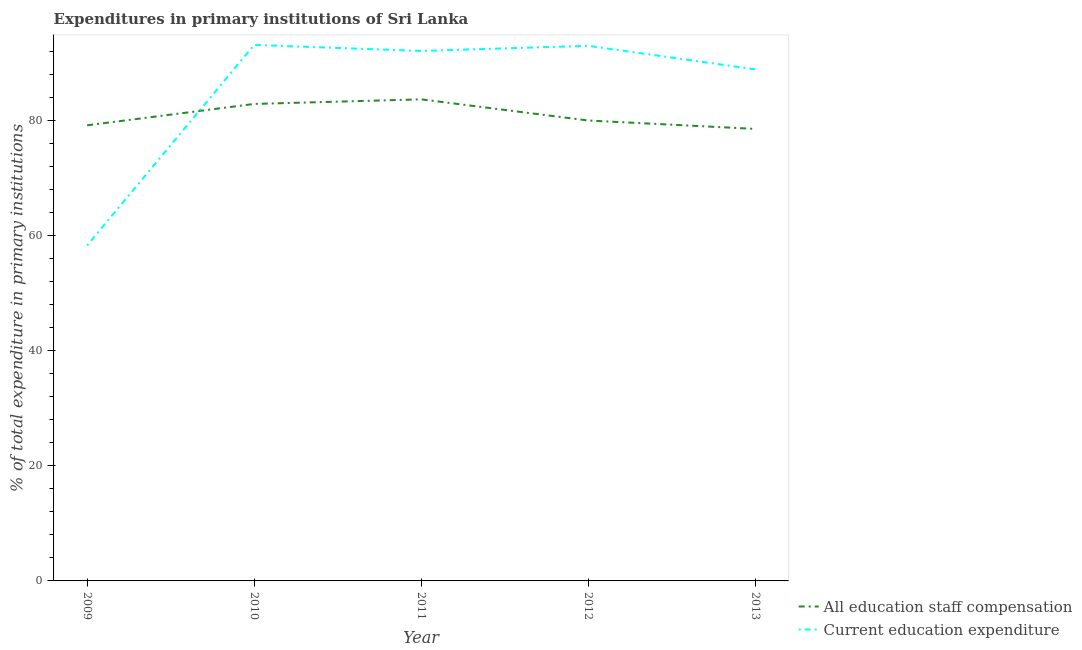What is the expenditure in staff compensation in 2012?
Provide a short and direct response. 80. Across all years, what is the maximum expenditure in education?
Your response must be concise. 93.14. Across all years, what is the minimum expenditure in education?
Keep it short and to the point. 58.29. What is the total expenditure in education in the graph?
Your answer should be compact. 425.41. What is the difference between the expenditure in education in 2012 and that in 2013?
Make the answer very short. 4.09. What is the difference between the expenditure in education in 2013 and the expenditure in staff compensation in 2012?
Keep it short and to the point. 8.89. What is the average expenditure in staff compensation per year?
Your response must be concise. 80.86. In the year 2009, what is the difference between the expenditure in education and expenditure in staff compensation?
Offer a very short reply. -20.88. In how many years, is the expenditure in education greater than 28 %?
Offer a very short reply. 5. What is the ratio of the expenditure in education in 2009 to that in 2012?
Provide a short and direct response. 0.63. Is the expenditure in staff compensation in 2009 less than that in 2010?
Your answer should be compact. Yes. Is the difference between the expenditure in education in 2012 and 2013 greater than the difference between the expenditure in staff compensation in 2012 and 2013?
Give a very brief answer. Yes. What is the difference between the highest and the second highest expenditure in staff compensation?
Make the answer very short. 0.8. What is the difference between the highest and the lowest expenditure in staff compensation?
Offer a terse response. 5.14. Does the expenditure in education monotonically increase over the years?
Make the answer very short. No. Is the expenditure in education strictly greater than the expenditure in staff compensation over the years?
Keep it short and to the point. No. How many years are there in the graph?
Ensure brevity in your answer.  5. What is the difference between two consecutive major ticks on the Y-axis?
Keep it short and to the point. 20. Does the graph contain any zero values?
Ensure brevity in your answer.  No. Does the graph contain grids?
Provide a short and direct response. No. How are the legend labels stacked?
Make the answer very short. Vertical. What is the title of the graph?
Your answer should be very brief. Expenditures in primary institutions of Sri Lanka. What is the label or title of the Y-axis?
Your answer should be very brief. % of total expenditure in primary institutions. What is the % of total expenditure in primary institutions of All education staff compensation in 2009?
Provide a short and direct response. 79.17. What is the % of total expenditure in primary institutions in Current education expenditure in 2009?
Make the answer very short. 58.29. What is the % of total expenditure in primary institutions of All education staff compensation in 2010?
Your answer should be very brief. 82.88. What is the % of total expenditure in primary institutions of Current education expenditure in 2010?
Provide a succinct answer. 93.14. What is the % of total expenditure in primary institutions in All education staff compensation in 2011?
Ensure brevity in your answer.  83.68. What is the % of total expenditure in primary institutions of Current education expenditure in 2011?
Offer a terse response. 92.09. What is the % of total expenditure in primary institutions of All education staff compensation in 2012?
Your response must be concise. 80. What is the % of total expenditure in primary institutions in Current education expenditure in 2012?
Your answer should be compact. 92.98. What is the % of total expenditure in primary institutions in All education staff compensation in 2013?
Give a very brief answer. 78.55. What is the % of total expenditure in primary institutions of Current education expenditure in 2013?
Offer a terse response. 88.89. Across all years, what is the maximum % of total expenditure in primary institutions of All education staff compensation?
Offer a very short reply. 83.68. Across all years, what is the maximum % of total expenditure in primary institutions in Current education expenditure?
Provide a succinct answer. 93.14. Across all years, what is the minimum % of total expenditure in primary institutions of All education staff compensation?
Provide a succinct answer. 78.55. Across all years, what is the minimum % of total expenditure in primary institutions of Current education expenditure?
Keep it short and to the point. 58.29. What is the total % of total expenditure in primary institutions in All education staff compensation in the graph?
Offer a terse response. 404.29. What is the total % of total expenditure in primary institutions of Current education expenditure in the graph?
Make the answer very short. 425.41. What is the difference between the % of total expenditure in primary institutions in All education staff compensation in 2009 and that in 2010?
Provide a short and direct response. -3.71. What is the difference between the % of total expenditure in primary institutions of Current education expenditure in 2009 and that in 2010?
Offer a terse response. -34.85. What is the difference between the % of total expenditure in primary institutions in All education staff compensation in 2009 and that in 2011?
Offer a terse response. -4.51. What is the difference between the % of total expenditure in primary institutions in Current education expenditure in 2009 and that in 2011?
Offer a very short reply. -33.8. What is the difference between the % of total expenditure in primary institutions of All education staff compensation in 2009 and that in 2012?
Offer a terse response. -0.83. What is the difference between the % of total expenditure in primary institutions in Current education expenditure in 2009 and that in 2012?
Your response must be concise. -34.69. What is the difference between the % of total expenditure in primary institutions of All education staff compensation in 2009 and that in 2013?
Your answer should be compact. 0.63. What is the difference between the % of total expenditure in primary institutions of Current education expenditure in 2009 and that in 2013?
Your answer should be very brief. -30.6. What is the difference between the % of total expenditure in primary institutions in All education staff compensation in 2010 and that in 2011?
Offer a very short reply. -0.8. What is the difference between the % of total expenditure in primary institutions of Current education expenditure in 2010 and that in 2011?
Your answer should be very brief. 1.05. What is the difference between the % of total expenditure in primary institutions of All education staff compensation in 2010 and that in 2012?
Offer a terse response. 2.88. What is the difference between the % of total expenditure in primary institutions in Current education expenditure in 2010 and that in 2012?
Your answer should be very brief. 0.16. What is the difference between the % of total expenditure in primary institutions of All education staff compensation in 2010 and that in 2013?
Offer a very short reply. 4.34. What is the difference between the % of total expenditure in primary institutions in Current education expenditure in 2010 and that in 2013?
Offer a terse response. 4.25. What is the difference between the % of total expenditure in primary institutions of All education staff compensation in 2011 and that in 2012?
Your answer should be compact. 3.68. What is the difference between the % of total expenditure in primary institutions of Current education expenditure in 2011 and that in 2012?
Your answer should be compact. -0.89. What is the difference between the % of total expenditure in primary institutions in All education staff compensation in 2011 and that in 2013?
Your answer should be compact. 5.14. What is the difference between the % of total expenditure in primary institutions of Current education expenditure in 2011 and that in 2013?
Offer a very short reply. 3.2. What is the difference between the % of total expenditure in primary institutions in All education staff compensation in 2012 and that in 2013?
Provide a short and direct response. 1.46. What is the difference between the % of total expenditure in primary institutions of Current education expenditure in 2012 and that in 2013?
Give a very brief answer. 4.09. What is the difference between the % of total expenditure in primary institutions in All education staff compensation in 2009 and the % of total expenditure in primary institutions in Current education expenditure in 2010?
Make the answer very short. -13.97. What is the difference between the % of total expenditure in primary institutions of All education staff compensation in 2009 and the % of total expenditure in primary institutions of Current education expenditure in 2011?
Your response must be concise. -12.92. What is the difference between the % of total expenditure in primary institutions of All education staff compensation in 2009 and the % of total expenditure in primary institutions of Current education expenditure in 2012?
Offer a terse response. -13.81. What is the difference between the % of total expenditure in primary institutions of All education staff compensation in 2009 and the % of total expenditure in primary institutions of Current education expenditure in 2013?
Keep it short and to the point. -9.72. What is the difference between the % of total expenditure in primary institutions in All education staff compensation in 2010 and the % of total expenditure in primary institutions in Current education expenditure in 2011?
Make the answer very short. -9.21. What is the difference between the % of total expenditure in primary institutions of All education staff compensation in 2010 and the % of total expenditure in primary institutions of Current education expenditure in 2012?
Your answer should be very brief. -10.1. What is the difference between the % of total expenditure in primary institutions in All education staff compensation in 2010 and the % of total expenditure in primary institutions in Current education expenditure in 2013?
Your answer should be very brief. -6.01. What is the difference between the % of total expenditure in primary institutions of All education staff compensation in 2011 and the % of total expenditure in primary institutions of Current education expenditure in 2012?
Give a very brief answer. -9.3. What is the difference between the % of total expenditure in primary institutions of All education staff compensation in 2011 and the % of total expenditure in primary institutions of Current education expenditure in 2013?
Ensure brevity in your answer.  -5.21. What is the difference between the % of total expenditure in primary institutions of All education staff compensation in 2012 and the % of total expenditure in primary institutions of Current education expenditure in 2013?
Provide a succinct answer. -8.89. What is the average % of total expenditure in primary institutions of All education staff compensation per year?
Give a very brief answer. 80.86. What is the average % of total expenditure in primary institutions in Current education expenditure per year?
Give a very brief answer. 85.08. In the year 2009, what is the difference between the % of total expenditure in primary institutions of All education staff compensation and % of total expenditure in primary institutions of Current education expenditure?
Ensure brevity in your answer.  20.88. In the year 2010, what is the difference between the % of total expenditure in primary institutions in All education staff compensation and % of total expenditure in primary institutions in Current education expenditure?
Your answer should be compact. -10.26. In the year 2011, what is the difference between the % of total expenditure in primary institutions in All education staff compensation and % of total expenditure in primary institutions in Current education expenditure?
Give a very brief answer. -8.41. In the year 2012, what is the difference between the % of total expenditure in primary institutions in All education staff compensation and % of total expenditure in primary institutions in Current education expenditure?
Your answer should be very brief. -12.98. In the year 2013, what is the difference between the % of total expenditure in primary institutions of All education staff compensation and % of total expenditure in primary institutions of Current education expenditure?
Your response must be concise. -10.35. What is the ratio of the % of total expenditure in primary institutions in All education staff compensation in 2009 to that in 2010?
Give a very brief answer. 0.96. What is the ratio of the % of total expenditure in primary institutions of Current education expenditure in 2009 to that in 2010?
Offer a very short reply. 0.63. What is the ratio of the % of total expenditure in primary institutions in All education staff compensation in 2009 to that in 2011?
Provide a succinct answer. 0.95. What is the ratio of the % of total expenditure in primary institutions in Current education expenditure in 2009 to that in 2011?
Your answer should be very brief. 0.63. What is the ratio of the % of total expenditure in primary institutions of Current education expenditure in 2009 to that in 2012?
Provide a short and direct response. 0.63. What is the ratio of the % of total expenditure in primary institutions of Current education expenditure in 2009 to that in 2013?
Offer a terse response. 0.66. What is the ratio of the % of total expenditure in primary institutions in All education staff compensation in 2010 to that in 2011?
Your response must be concise. 0.99. What is the ratio of the % of total expenditure in primary institutions of Current education expenditure in 2010 to that in 2011?
Make the answer very short. 1.01. What is the ratio of the % of total expenditure in primary institutions in All education staff compensation in 2010 to that in 2012?
Your answer should be very brief. 1.04. What is the ratio of the % of total expenditure in primary institutions in All education staff compensation in 2010 to that in 2013?
Provide a succinct answer. 1.06. What is the ratio of the % of total expenditure in primary institutions in Current education expenditure in 2010 to that in 2013?
Offer a terse response. 1.05. What is the ratio of the % of total expenditure in primary institutions in All education staff compensation in 2011 to that in 2012?
Your answer should be very brief. 1.05. What is the ratio of the % of total expenditure in primary institutions of All education staff compensation in 2011 to that in 2013?
Provide a succinct answer. 1.07. What is the ratio of the % of total expenditure in primary institutions of Current education expenditure in 2011 to that in 2013?
Give a very brief answer. 1.04. What is the ratio of the % of total expenditure in primary institutions in All education staff compensation in 2012 to that in 2013?
Provide a succinct answer. 1.02. What is the ratio of the % of total expenditure in primary institutions in Current education expenditure in 2012 to that in 2013?
Ensure brevity in your answer.  1.05. What is the difference between the highest and the second highest % of total expenditure in primary institutions in All education staff compensation?
Provide a succinct answer. 0.8. What is the difference between the highest and the second highest % of total expenditure in primary institutions of Current education expenditure?
Your response must be concise. 0.16. What is the difference between the highest and the lowest % of total expenditure in primary institutions in All education staff compensation?
Offer a very short reply. 5.14. What is the difference between the highest and the lowest % of total expenditure in primary institutions in Current education expenditure?
Your response must be concise. 34.85. 